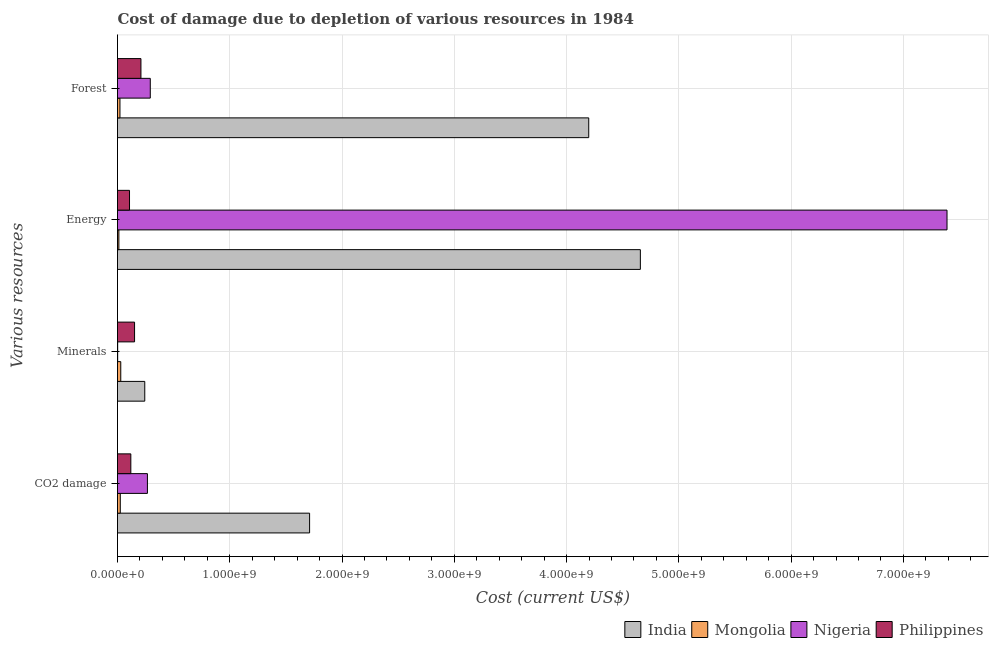Are the number of bars per tick equal to the number of legend labels?
Your response must be concise. Yes. How many bars are there on the 1st tick from the bottom?
Ensure brevity in your answer.  4. What is the label of the 1st group of bars from the top?
Offer a very short reply. Forest. What is the cost of damage due to depletion of energy in Mongolia?
Your response must be concise. 1.22e+07. Across all countries, what is the maximum cost of damage due to depletion of coal?
Give a very brief answer. 1.71e+09. Across all countries, what is the minimum cost of damage due to depletion of minerals?
Keep it short and to the point. 1.48e+06. In which country was the cost of damage due to depletion of energy maximum?
Offer a very short reply. Nigeria. In which country was the cost of damage due to depletion of minerals minimum?
Offer a very short reply. Nigeria. What is the total cost of damage due to depletion of forests in the graph?
Keep it short and to the point. 4.72e+09. What is the difference between the cost of damage due to depletion of minerals in Nigeria and that in India?
Offer a terse response. -2.41e+08. What is the difference between the cost of damage due to depletion of minerals in Nigeria and the cost of damage due to depletion of energy in India?
Give a very brief answer. -4.66e+09. What is the average cost of damage due to depletion of energy per country?
Your response must be concise. 3.04e+09. What is the difference between the cost of damage due to depletion of coal and cost of damage due to depletion of minerals in Philippines?
Offer a terse response. -3.33e+07. In how many countries, is the cost of damage due to depletion of forests greater than 7200000000 US$?
Offer a very short reply. 0. What is the ratio of the cost of damage due to depletion of coal in Mongolia to that in Nigeria?
Provide a short and direct response. 0.09. What is the difference between the highest and the second highest cost of damage due to depletion of forests?
Ensure brevity in your answer.  3.91e+09. What is the difference between the highest and the lowest cost of damage due to depletion of forests?
Provide a succinct answer. 4.18e+09. Is the sum of the cost of damage due to depletion of energy in Philippines and Mongolia greater than the maximum cost of damage due to depletion of coal across all countries?
Your answer should be very brief. No. What does the 3rd bar from the top in Energy represents?
Make the answer very short. Mongolia. Is it the case that in every country, the sum of the cost of damage due to depletion of coal and cost of damage due to depletion of minerals is greater than the cost of damage due to depletion of energy?
Provide a short and direct response. No. How many bars are there?
Provide a succinct answer. 16. Are all the bars in the graph horizontal?
Give a very brief answer. Yes. How many countries are there in the graph?
Give a very brief answer. 4. Are the values on the major ticks of X-axis written in scientific E-notation?
Give a very brief answer. Yes. Does the graph contain any zero values?
Provide a short and direct response. No. Where does the legend appear in the graph?
Your answer should be compact. Bottom right. How many legend labels are there?
Offer a terse response. 4. What is the title of the graph?
Offer a very short reply. Cost of damage due to depletion of various resources in 1984 . What is the label or title of the X-axis?
Your answer should be very brief. Cost (current US$). What is the label or title of the Y-axis?
Keep it short and to the point. Various resources. What is the Cost (current US$) of India in CO2 damage?
Provide a succinct answer. 1.71e+09. What is the Cost (current US$) of Mongolia in CO2 damage?
Give a very brief answer. 2.47e+07. What is the Cost (current US$) in Nigeria in CO2 damage?
Provide a succinct answer. 2.66e+08. What is the Cost (current US$) of Philippines in CO2 damage?
Keep it short and to the point. 1.19e+08. What is the Cost (current US$) of India in Minerals?
Offer a very short reply. 2.43e+08. What is the Cost (current US$) of Mongolia in Minerals?
Provide a succinct answer. 2.90e+07. What is the Cost (current US$) in Nigeria in Minerals?
Make the answer very short. 1.48e+06. What is the Cost (current US$) of Philippines in Minerals?
Make the answer very short. 1.52e+08. What is the Cost (current US$) of India in Energy?
Offer a very short reply. 4.66e+09. What is the Cost (current US$) in Mongolia in Energy?
Provide a short and direct response. 1.22e+07. What is the Cost (current US$) of Nigeria in Energy?
Your answer should be compact. 7.39e+09. What is the Cost (current US$) of Philippines in Energy?
Offer a terse response. 1.07e+08. What is the Cost (current US$) in India in Forest?
Your answer should be very brief. 4.20e+09. What is the Cost (current US$) in Mongolia in Forest?
Provide a succinct answer. 2.18e+07. What is the Cost (current US$) in Nigeria in Forest?
Keep it short and to the point. 2.92e+08. What is the Cost (current US$) in Philippines in Forest?
Provide a succinct answer. 2.09e+08. Across all Various resources, what is the maximum Cost (current US$) of India?
Make the answer very short. 4.66e+09. Across all Various resources, what is the maximum Cost (current US$) in Mongolia?
Provide a succinct answer. 2.90e+07. Across all Various resources, what is the maximum Cost (current US$) of Nigeria?
Your answer should be compact. 7.39e+09. Across all Various resources, what is the maximum Cost (current US$) of Philippines?
Make the answer very short. 2.09e+08. Across all Various resources, what is the minimum Cost (current US$) of India?
Your answer should be compact. 2.43e+08. Across all Various resources, what is the minimum Cost (current US$) in Mongolia?
Offer a terse response. 1.22e+07. Across all Various resources, what is the minimum Cost (current US$) of Nigeria?
Keep it short and to the point. 1.48e+06. Across all Various resources, what is the minimum Cost (current US$) in Philippines?
Offer a terse response. 1.07e+08. What is the total Cost (current US$) of India in the graph?
Provide a succinct answer. 1.08e+1. What is the total Cost (current US$) in Mongolia in the graph?
Keep it short and to the point. 8.76e+07. What is the total Cost (current US$) in Nigeria in the graph?
Keep it short and to the point. 7.95e+09. What is the total Cost (current US$) of Philippines in the graph?
Your answer should be very brief. 5.86e+08. What is the difference between the Cost (current US$) of India in CO2 damage and that in Minerals?
Keep it short and to the point. 1.47e+09. What is the difference between the Cost (current US$) of Mongolia in CO2 damage and that in Minerals?
Provide a short and direct response. -4.30e+06. What is the difference between the Cost (current US$) in Nigeria in CO2 damage and that in Minerals?
Your answer should be very brief. 2.65e+08. What is the difference between the Cost (current US$) in Philippines in CO2 damage and that in Minerals?
Make the answer very short. -3.33e+07. What is the difference between the Cost (current US$) of India in CO2 damage and that in Energy?
Ensure brevity in your answer.  -2.95e+09. What is the difference between the Cost (current US$) in Mongolia in CO2 damage and that in Energy?
Offer a very short reply. 1.25e+07. What is the difference between the Cost (current US$) in Nigeria in CO2 damage and that in Energy?
Make the answer very short. -7.12e+09. What is the difference between the Cost (current US$) in Philippines in CO2 damage and that in Energy?
Make the answer very short. 1.17e+07. What is the difference between the Cost (current US$) in India in CO2 damage and that in Forest?
Give a very brief answer. -2.49e+09. What is the difference between the Cost (current US$) of Mongolia in CO2 damage and that in Forest?
Keep it short and to the point. 2.88e+06. What is the difference between the Cost (current US$) of Nigeria in CO2 damage and that in Forest?
Give a very brief answer. -2.55e+07. What is the difference between the Cost (current US$) of Philippines in CO2 damage and that in Forest?
Your answer should be compact. -9.01e+07. What is the difference between the Cost (current US$) of India in Minerals and that in Energy?
Offer a terse response. -4.41e+09. What is the difference between the Cost (current US$) of Mongolia in Minerals and that in Energy?
Ensure brevity in your answer.  1.68e+07. What is the difference between the Cost (current US$) of Nigeria in Minerals and that in Energy?
Offer a very short reply. -7.39e+09. What is the difference between the Cost (current US$) in Philippines in Minerals and that in Energy?
Provide a short and direct response. 4.50e+07. What is the difference between the Cost (current US$) of India in Minerals and that in Forest?
Give a very brief answer. -3.95e+09. What is the difference between the Cost (current US$) of Mongolia in Minerals and that in Forest?
Make the answer very short. 7.18e+06. What is the difference between the Cost (current US$) in Nigeria in Minerals and that in Forest?
Provide a short and direct response. -2.90e+08. What is the difference between the Cost (current US$) in Philippines in Minerals and that in Forest?
Ensure brevity in your answer.  -5.68e+07. What is the difference between the Cost (current US$) of India in Energy and that in Forest?
Keep it short and to the point. 4.60e+08. What is the difference between the Cost (current US$) of Mongolia in Energy and that in Forest?
Give a very brief answer. -9.63e+06. What is the difference between the Cost (current US$) of Nigeria in Energy and that in Forest?
Keep it short and to the point. 7.10e+09. What is the difference between the Cost (current US$) in Philippines in Energy and that in Forest?
Offer a terse response. -1.02e+08. What is the difference between the Cost (current US$) in India in CO2 damage and the Cost (current US$) in Mongolia in Minerals?
Offer a terse response. 1.68e+09. What is the difference between the Cost (current US$) of India in CO2 damage and the Cost (current US$) of Nigeria in Minerals?
Make the answer very short. 1.71e+09. What is the difference between the Cost (current US$) in India in CO2 damage and the Cost (current US$) in Philippines in Minerals?
Offer a very short reply. 1.56e+09. What is the difference between the Cost (current US$) of Mongolia in CO2 damage and the Cost (current US$) of Nigeria in Minerals?
Your answer should be compact. 2.32e+07. What is the difference between the Cost (current US$) of Mongolia in CO2 damage and the Cost (current US$) of Philippines in Minerals?
Provide a short and direct response. -1.27e+08. What is the difference between the Cost (current US$) of Nigeria in CO2 damage and the Cost (current US$) of Philippines in Minerals?
Make the answer very short. 1.15e+08. What is the difference between the Cost (current US$) in India in CO2 damage and the Cost (current US$) in Mongolia in Energy?
Your answer should be compact. 1.70e+09. What is the difference between the Cost (current US$) in India in CO2 damage and the Cost (current US$) in Nigeria in Energy?
Your answer should be compact. -5.68e+09. What is the difference between the Cost (current US$) of India in CO2 damage and the Cost (current US$) of Philippines in Energy?
Provide a short and direct response. 1.60e+09. What is the difference between the Cost (current US$) in Mongolia in CO2 damage and the Cost (current US$) in Nigeria in Energy?
Your answer should be compact. -7.36e+09. What is the difference between the Cost (current US$) in Mongolia in CO2 damage and the Cost (current US$) in Philippines in Energy?
Your answer should be very brief. -8.22e+07. What is the difference between the Cost (current US$) of Nigeria in CO2 damage and the Cost (current US$) of Philippines in Energy?
Offer a very short reply. 1.60e+08. What is the difference between the Cost (current US$) in India in CO2 damage and the Cost (current US$) in Mongolia in Forest?
Keep it short and to the point. 1.69e+09. What is the difference between the Cost (current US$) of India in CO2 damage and the Cost (current US$) of Nigeria in Forest?
Your answer should be very brief. 1.42e+09. What is the difference between the Cost (current US$) in India in CO2 damage and the Cost (current US$) in Philippines in Forest?
Your answer should be very brief. 1.50e+09. What is the difference between the Cost (current US$) of Mongolia in CO2 damage and the Cost (current US$) of Nigeria in Forest?
Keep it short and to the point. -2.67e+08. What is the difference between the Cost (current US$) of Mongolia in CO2 damage and the Cost (current US$) of Philippines in Forest?
Provide a succinct answer. -1.84e+08. What is the difference between the Cost (current US$) in Nigeria in CO2 damage and the Cost (current US$) in Philippines in Forest?
Give a very brief answer. 5.78e+07. What is the difference between the Cost (current US$) in India in Minerals and the Cost (current US$) in Mongolia in Energy?
Your response must be concise. 2.31e+08. What is the difference between the Cost (current US$) in India in Minerals and the Cost (current US$) in Nigeria in Energy?
Make the answer very short. -7.15e+09. What is the difference between the Cost (current US$) of India in Minerals and the Cost (current US$) of Philippines in Energy?
Provide a succinct answer. 1.36e+08. What is the difference between the Cost (current US$) in Mongolia in Minerals and the Cost (current US$) in Nigeria in Energy?
Provide a short and direct response. -7.36e+09. What is the difference between the Cost (current US$) in Mongolia in Minerals and the Cost (current US$) in Philippines in Energy?
Give a very brief answer. -7.79e+07. What is the difference between the Cost (current US$) of Nigeria in Minerals and the Cost (current US$) of Philippines in Energy?
Make the answer very short. -1.05e+08. What is the difference between the Cost (current US$) of India in Minerals and the Cost (current US$) of Mongolia in Forest?
Your response must be concise. 2.21e+08. What is the difference between the Cost (current US$) of India in Minerals and the Cost (current US$) of Nigeria in Forest?
Your answer should be very brief. -4.90e+07. What is the difference between the Cost (current US$) of India in Minerals and the Cost (current US$) of Philippines in Forest?
Offer a terse response. 3.42e+07. What is the difference between the Cost (current US$) of Mongolia in Minerals and the Cost (current US$) of Nigeria in Forest?
Offer a very short reply. -2.63e+08. What is the difference between the Cost (current US$) of Mongolia in Minerals and the Cost (current US$) of Philippines in Forest?
Offer a very short reply. -1.80e+08. What is the difference between the Cost (current US$) of Nigeria in Minerals and the Cost (current US$) of Philippines in Forest?
Your answer should be compact. -2.07e+08. What is the difference between the Cost (current US$) of India in Energy and the Cost (current US$) of Mongolia in Forest?
Offer a very short reply. 4.64e+09. What is the difference between the Cost (current US$) in India in Energy and the Cost (current US$) in Nigeria in Forest?
Ensure brevity in your answer.  4.37e+09. What is the difference between the Cost (current US$) of India in Energy and the Cost (current US$) of Philippines in Forest?
Your answer should be very brief. 4.45e+09. What is the difference between the Cost (current US$) of Mongolia in Energy and the Cost (current US$) of Nigeria in Forest?
Your answer should be very brief. -2.80e+08. What is the difference between the Cost (current US$) of Mongolia in Energy and the Cost (current US$) of Philippines in Forest?
Your answer should be compact. -1.96e+08. What is the difference between the Cost (current US$) of Nigeria in Energy and the Cost (current US$) of Philippines in Forest?
Make the answer very short. 7.18e+09. What is the average Cost (current US$) of India per Various resources?
Give a very brief answer. 2.70e+09. What is the average Cost (current US$) in Mongolia per Various resources?
Your response must be concise. 2.19e+07. What is the average Cost (current US$) of Nigeria per Various resources?
Provide a short and direct response. 1.99e+09. What is the average Cost (current US$) in Philippines per Various resources?
Offer a very short reply. 1.47e+08. What is the difference between the Cost (current US$) in India and Cost (current US$) in Mongolia in CO2 damage?
Make the answer very short. 1.69e+09. What is the difference between the Cost (current US$) in India and Cost (current US$) in Nigeria in CO2 damage?
Your answer should be very brief. 1.44e+09. What is the difference between the Cost (current US$) in India and Cost (current US$) in Philippines in CO2 damage?
Your answer should be compact. 1.59e+09. What is the difference between the Cost (current US$) in Mongolia and Cost (current US$) in Nigeria in CO2 damage?
Ensure brevity in your answer.  -2.42e+08. What is the difference between the Cost (current US$) in Mongolia and Cost (current US$) in Philippines in CO2 damage?
Your answer should be very brief. -9.39e+07. What is the difference between the Cost (current US$) of Nigeria and Cost (current US$) of Philippines in CO2 damage?
Your answer should be very brief. 1.48e+08. What is the difference between the Cost (current US$) in India and Cost (current US$) in Mongolia in Minerals?
Offer a very short reply. 2.14e+08. What is the difference between the Cost (current US$) in India and Cost (current US$) in Nigeria in Minerals?
Your answer should be very brief. 2.41e+08. What is the difference between the Cost (current US$) in India and Cost (current US$) in Philippines in Minerals?
Provide a succinct answer. 9.10e+07. What is the difference between the Cost (current US$) of Mongolia and Cost (current US$) of Nigeria in Minerals?
Your answer should be compact. 2.75e+07. What is the difference between the Cost (current US$) in Mongolia and Cost (current US$) in Philippines in Minerals?
Your response must be concise. -1.23e+08. What is the difference between the Cost (current US$) of Nigeria and Cost (current US$) of Philippines in Minerals?
Provide a succinct answer. -1.50e+08. What is the difference between the Cost (current US$) in India and Cost (current US$) in Mongolia in Energy?
Your response must be concise. 4.65e+09. What is the difference between the Cost (current US$) in India and Cost (current US$) in Nigeria in Energy?
Make the answer very short. -2.73e+09. What is the difference between the Cost (current US$) of India and Cost (current US$) of Philippines in Energy?
Make the answer very short. 4.55e+09. What is the difference between the Cost (current US$) of Mongolia and Cost (current US$) of Nigeria in Energy?
Provide a short and direct response. -7.38e+09. What is the difference between the Cost (current US$) in Mongolia and Cost (current US$) in Philippines in Energy?
Offer a very short reply. -9.47e+07. What is the difference between the Cost (current US$) in Nigeria and Cost (current US$) in Philippines in Energy?
Your answer should be compact. 7.28e+09. What is the difference between the Cost (current US$) of India and Cost (current US$) of Mongolia in Forest?
Your answer should be compact. 4.18e+09. What is the difference between the Cost (current US$) of India and Cost (current US$) of Nigeria in Forest?
Offer a very short reply. 3.91e+09. What is the difference between the Cost (current US$) of India and Cost (current US$) of Philippines in Forest?
Your response must be concise. 3.99e+09. What is the difference between the Cost (current US$) of Mongolia and Cost (current US$) of Nigeria in Forest?
Your answer should be very brief. -2.70e+08. What is the difference between the Cost (current US$) of Mongolia and Cost (current US$) of Philippines in Forest?
Provide a succinct answer. -1.87e+08. What is the difference between the Cost (current US$) of Nigeria and Cost (current US$) of Philippines in Forest?
Ensure brevity in your answer.  8.32e+07. What is the ratio of the Cost (current US$) of India in CO2 damage to that in Minerals?
Offer a very short reply. 7.04. What is the ratio of the Cost (current US$) of Mongolia in CO2 damage to that in Minerals?
Provide a short and direct response. 0.85. What is the ratio of the Cost (current US$) in Nigeria in CO2 damage to that in Minerals?
Offer a very short reply. 179.5. What is the ratio of the Cost (current US$) of Philippines in CO2 damage to that in Minerals?
Give a very brief answer. 0.78. What is the ratio of the Cost (current US$) in India in CO2 damage to that in Energy?
Your answer should be compact. 0.37. What is the ratio of the Cost (current US$) of Mongolia in CO2 damage to that in Energy?
Ensure brevity in your answer.  2.03. What is the ratio of the Cost (current US$) of Nigeria in CO2 damage to that in Energy?
Ensure brevity in your answer.  0.04. What is the ratio of the Cost (current US$) of Philippines in CO2 damage to that in Energy?
Your answer should be very brief. 1.11. What is the ratio of the Cost (current US$) in India in CO2 damage to that in Forest?
Provide a short and direct response. 0.41. What is the ratio of the Cost (current US$) of Mongolia in CO2 damage to that in Forest?
Give a very brief answer. 1.13. What is the ratio of the Cost (current US$) of Nigeria in CO2 damage to that in Forest?
Ensure brevity in your answer.  0.91. What is the ratio of the Cost (current US$) of Philippines in CO2 damage to that in Forest?
Provide a short and direct response. 0.57. What is the ratio of the Cost (current US$) of India in Minerals to that in Energy?
Make the answer very short. 0.05. What is the ratio of the Cost (current US$) of Mongolia in Minerals to that in Energy?
Offer a terse response. 2.38. What is the ratio of the Cost (current US$) of Nigeria in Minerals to that in Energy?
Ensure brevity in your answer.  0. What is the ratio of the Cost (current US$) of Philippines in Minerals to that in Energy?
Make the answer very short. 1.42. What is the ratio of the Cost (current US$) in India in Minerals to that in Forest?
Offer a very short reply. 0.06. What is the ratio of the Cost (current US$) of Mongolia in Minerals to that in Forest?
Keep it short and to the point. 1.33. What is the ratio of the Cost (current US$) in Nigeria in Minerals to that in Forest?
Provide a succinct answer. 0.01. What is the ratio of the Cost (current US$) of Philippines in Minerals to that in Forest?
Provide a short and direct response. 0.73. What is the ratio of the Cost (current US$) of India in Energy to that in Forest?
Your answer should be very brief. 1.11. What is the ratio of the Cost (current US$) in Mongolia in Energy to that in Forest?
Keep it short and to the point. 0.56. What is the ratio of the Cost (current US$) of Nigeria in Energy to that in Forest?
Make the answer very short. 25.31. What is the ratio of the Cost (current US$) in Philippines in Energy to that in Forest?
Your response must be concise. 0.51. What is the difference between the highest and the second highest Cost (current US$) of India?
Offer a very short reply. 4.60e+08. What is the difference between the highest and the second highest Cost (current US$) in Mongolia?
Your answer should be very brief. 4.30e+06. What is the difference between the highest and the second highest Cost (current US$) in Nigeria?
Give a very brief answer. 7.10e+09. What is the difference between the highest and the second highest Cost (current US$) in Philippines?
Offer a very short reply. 5.68e+07. What is the difference between the highest and the lowest Cost (current US$) in India?
Your answer should be compact. 4.41e+09. What is the difference between the highest and the lowest Cost (current US$) in Mongolia?
Your answer should be very brief. 1.68e+07. What is the difference between the highest and the lowest Cost (current US$) of Nigeria?
Keep it short and to the point. 7.39e+09. What is the difference between the highest and the lowest Cost (current US$) of Philippines?
Your response must be concise. 1.02e+08. 